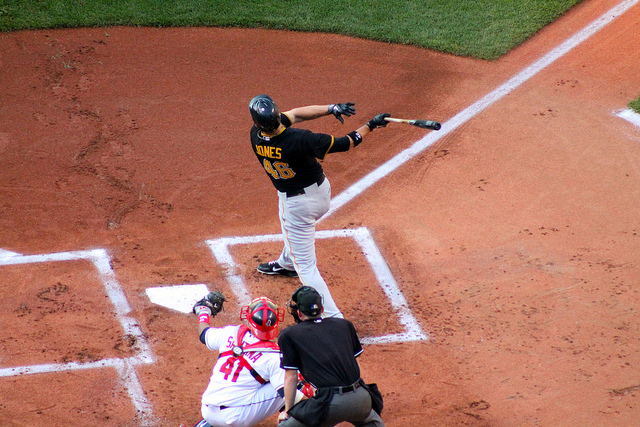Identify the text contained in this image. JONES 86 41 